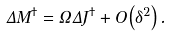Convert formula to latex. <formula><loc_0><loc_0><loc_500><loc_500>\Delta M ^ { \dag } = \Omega \Delta J ^ { \dag } + O \left ( \delta ^ { 2 } \right ) .</formula> 